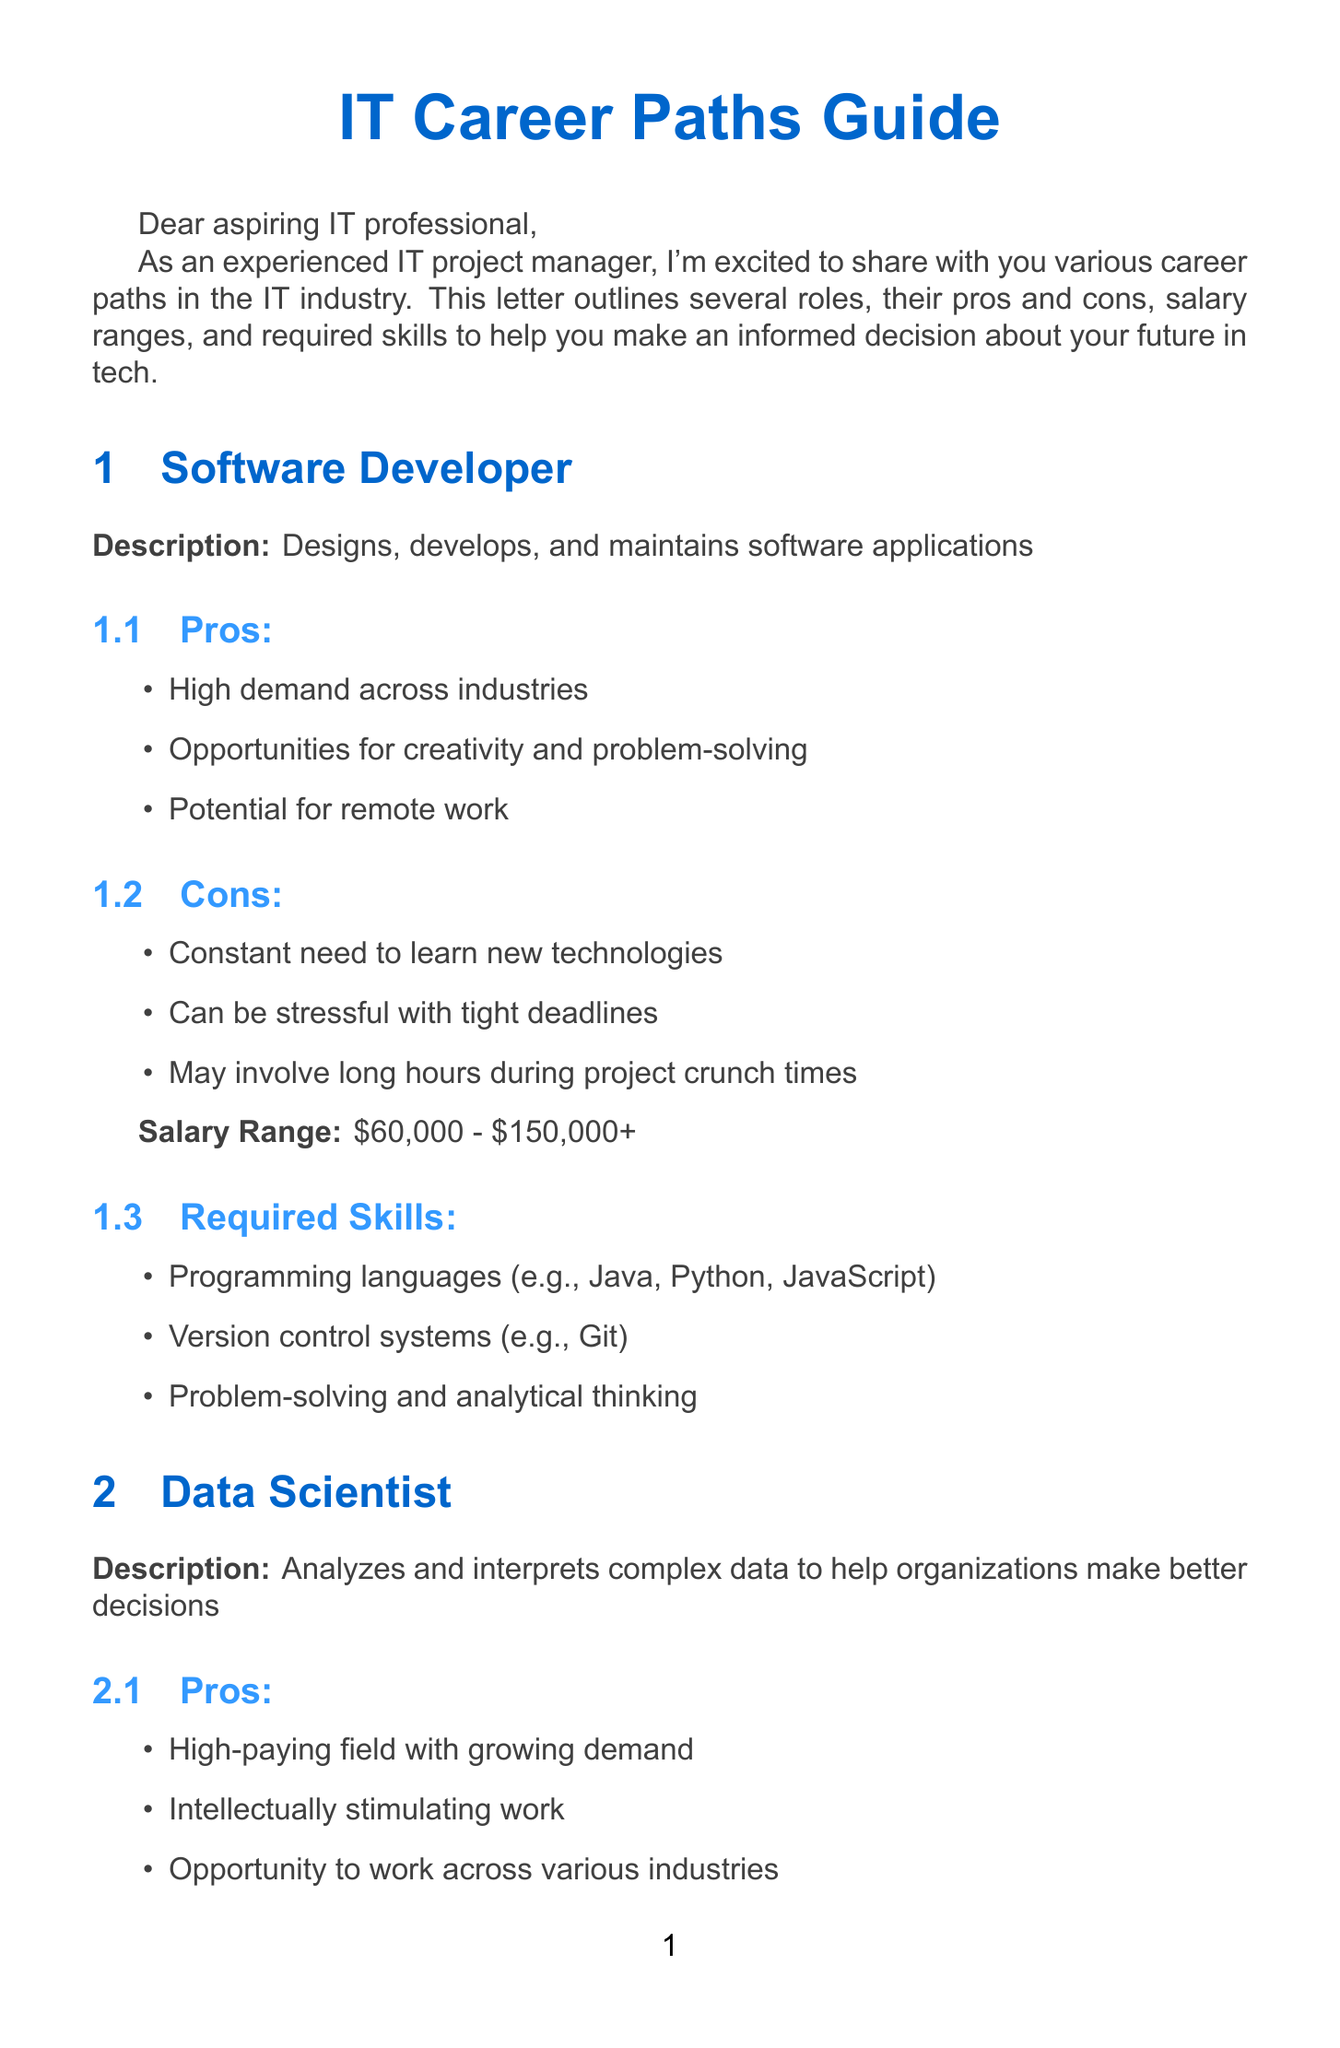what is the salary range for a Software Developer? The salary range for a Software Developer is stated directly in the document.
Answer: $60,000 - $150,000+ what are the required skills for a Data Scientist? The document specifies the required skills for a Data Scientist in a list format.
Answer: Statistics and machine learning, Programming (e.g., Python, R), Data visualization tools (e.g., Tableau, Power BI) which role offers a blend of creativity and technology? The document describes the UX/UI Designer role as having this characteristic.
Answer: UX/UI Designer what is a major con of being a Cybersecurity Analyst? The document lists several cons for each role, including challenges faced by Cybersecurity Analysts.
Answer: High-stress situations during security breaches how much can a Cloud Architect potentially earn? The document provides a salary range specifically for Cloud Architects.
Answer: $120,000 - $200,000+ what opportunity does being a Data Scientist provide? The document highlights the opportunity that comes with being a Data Scientist in the pros section.
Answer: Opportunity to work across various industries what is the main focus of a Software Developer? The document details the job description of a Software Developer.
Answer: Designs, develops, and maintains software applications name one of the required skills for a Cloud Architect. The document offers a list of skills required for the Cloud Architect role.
Answer: Cloud platforms (e.g., AWS, Azure, Google Cloud) what advice is given in the conclusion of the letter? The conclusion section of the document contains specific advice for career exploration.
Answer: Stay curious, keep learning, and don't be afraid to explore different areas to find your passion 